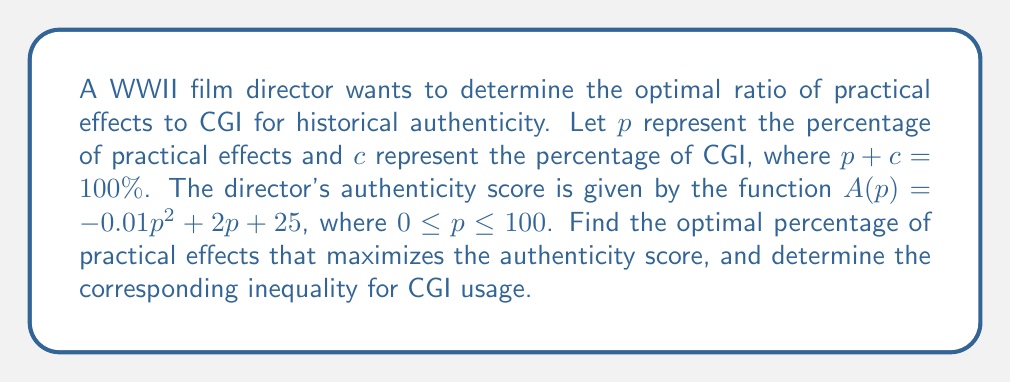Help me with this question. To find the optimal percentage of practical effects, we need to maximize the authenticity score function $A(p)$:

1. Find the derivative of $A(p)$:
   $$A'(p) = -0.02p + 2$$

2. Set the derivative to zero and solve for $p$:
   $$-0.02p + 2 = 0$$
   $$-0.02p = -2$$
   $$p = 100$$

3. Verify that this is a maximum by checking the second derivative:
   $$A''(p) = -0.02 < 0$$, confirming it's a maximum.

4. The optimal percentage of practical effects is 100%.

5. Since $p + c = 100\%$, we can express $c$ in terms of $p$:
   $$c = 100 - p$$

6. The inequality for CGI usage can be expressed as:
   $$c \leq 100 - 100 = 0$$

This means that for maximum historical authenticity, the film should use 100% practical effects and 0% CGI.
Answer: The optimal percentage of practical effects is 100%, and the corresponding inequality for CGI usage is $c \leq 0\%$. 